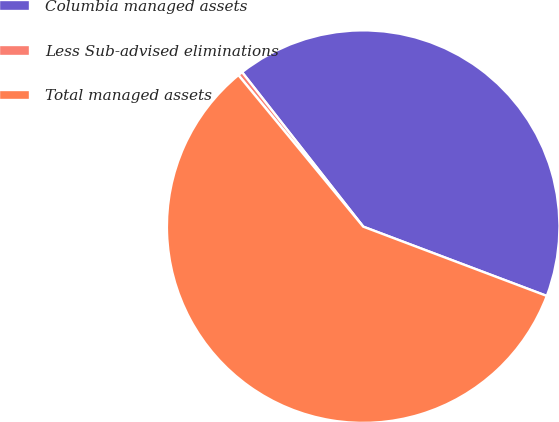Convert chart to OTSL. <chart><loc_0><loc_0><loc_500><loc_500><pie_chart><fcel>Columbia managed assets<fcel>Less Sub-advised eliminations<fcel>Total managed assets<nl><fcel>41.33%<fcel>0.38%<fcel>58.29%<nl></chart> 